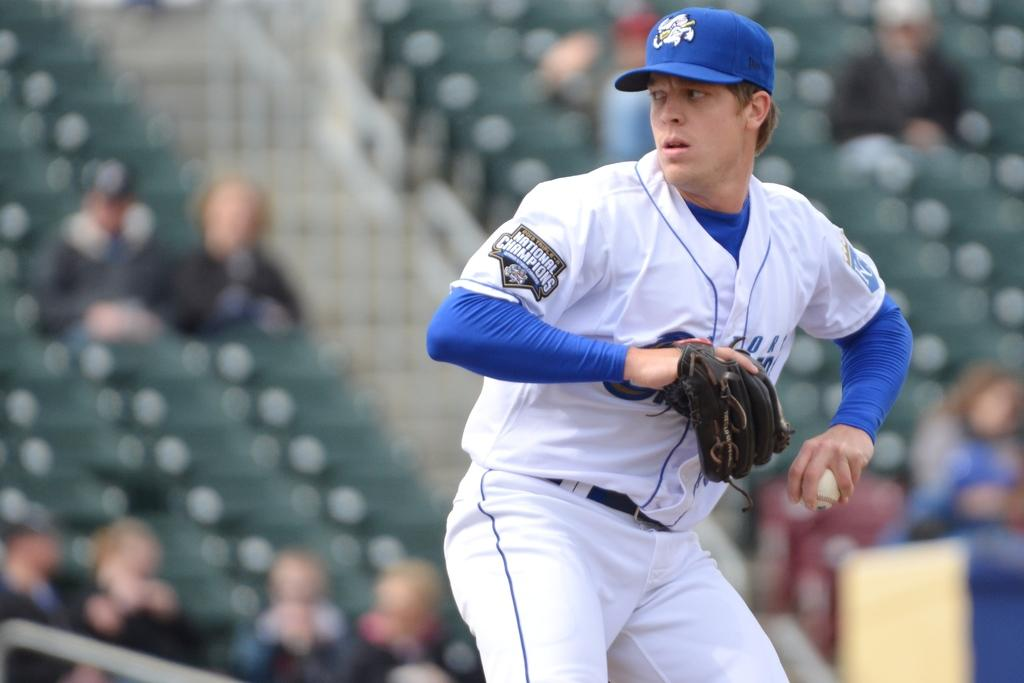<image>
Provide a brief description of the given image. A pitcher has a "National Champions" badge on his uniform sleeve. 